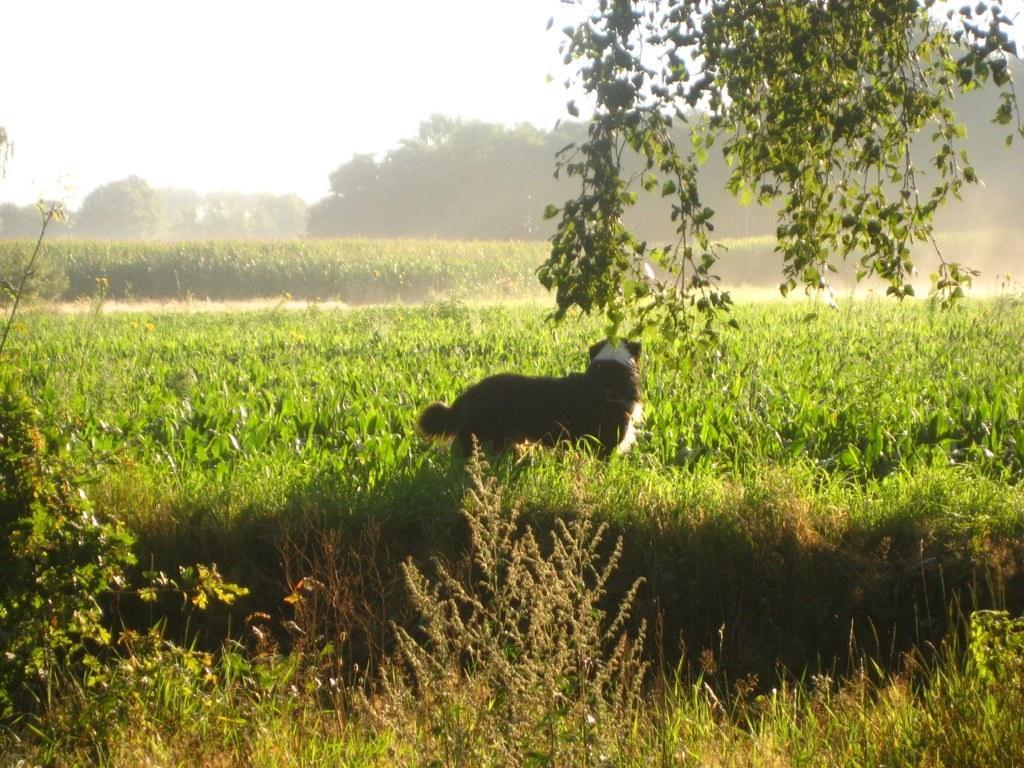Please provide a concise description of this image. In this image we can see an animal standing on the ground, plants, agricultural farms, trees and sky. 